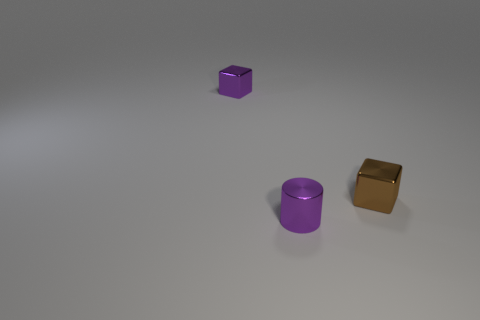Subtract all brown blocks. Subtract all cyan cylinders. How many blocks are left? 1 Add 1 blue rubber spheres. How many objects exist? 4 Subtract all cylinders. How many objects are left? 2 Subtract all small brown metal objects. Subtract all tiny blue rubber spheres. How many objects are left? 2 Add 3 brown metallic cubes. How many brown metallic cubes are left? 4 Add 3 big yellow rubber cylinders. How many big yellow rubber cylinders exist? 3 Subtract 1 purple blocks. How many objects are left? 2 